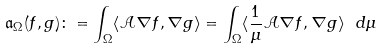Convert formula to latex. <formula><loc_0><loc_0><loc_500><loc_500>\mathfrak { a } _ { \Omega } ( f , g ) \colon = \int _ { \Omega } \langle \mathcal { A } \nabla f , \nabla g \rangle = \int _ { \Omega } \langle \frac { 1 } { \mu } \mathcal { A } \nabla f , \nabla g \rangle \ d \mu</formula> 